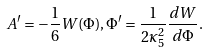<formula> <loc_0><loc_0><loc_500><loc_500>A ^ { \prime } = - \frac { 1 } { 6 } W ( \Phi ) , \Phi ^ { \prime } = \frac { 1 } { 2 \kappa _ { 5 } ^ { 2 } } \frac { d W } { d \Phi } .</formula> 